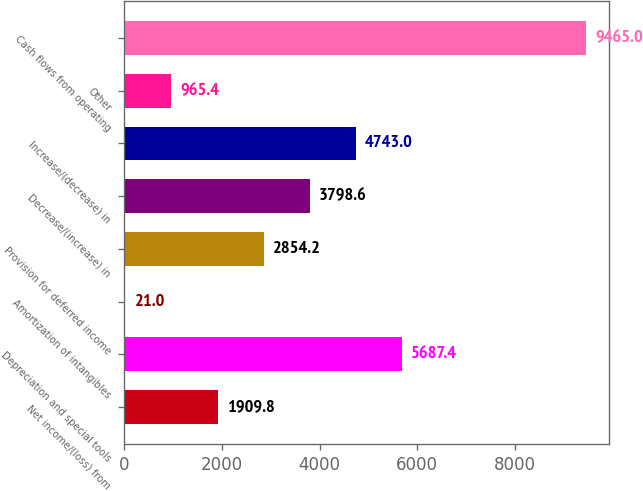Convert chart to OTSL. <chart><loc_0><loc_0><loc_500><loc_500><bar_chart><fcel>Net income/(loss) from<fcel>Depreciation and special tools<fcel>Amortization of intangibles<fcel>Provision for deferred income<fcel>Decrease/(increase) in<fcel>Increase/(decrease) in<fcel>Other<fcel>Cash flows from operating<nl><fcel>1909.8<fcel>5687.4<fcel>21<fcel>2854.2<fcel>3798.6<fcel>4743<fcel>965.4<fcel>9465<nl></chart> 